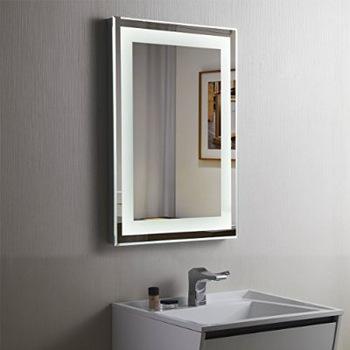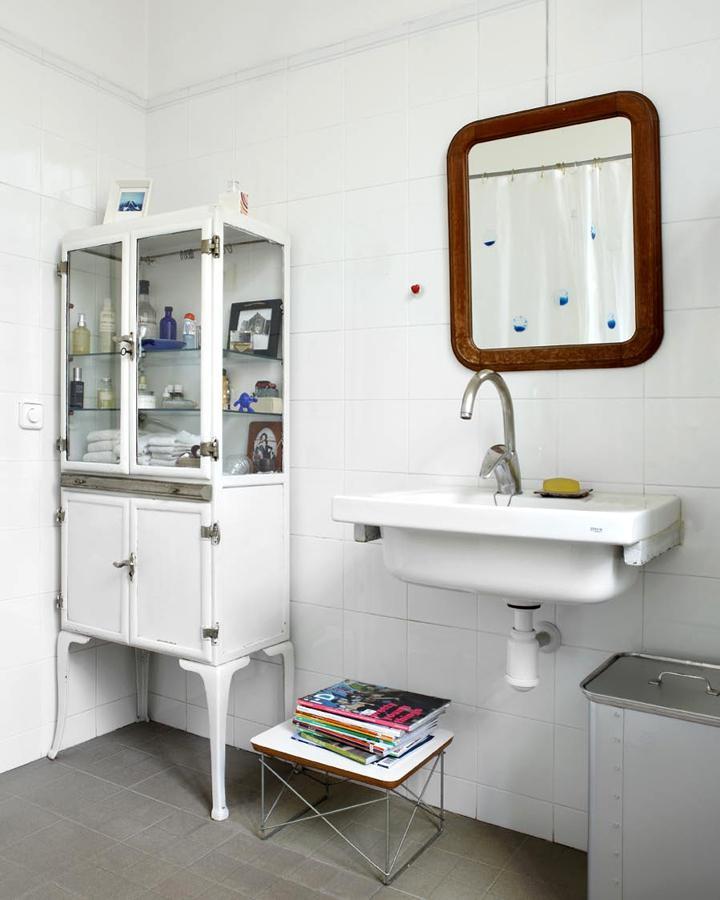The first image is the image on the left, the second image is the image on the right. Examine the images to the left and right. Is the description "In one image, a vanity the width of one sink has two doors and stands on short legs." accurate? Answer yes or no. No. The first image is the image on the left, the second image is the image on the right. Assess this claim about the two images: "One image contains a single sink over a cabinet on short legs with double doors, and the other image includes a long vanity with two inset white rectangular sinks.". Correct or not? Answer yes or no. No. 